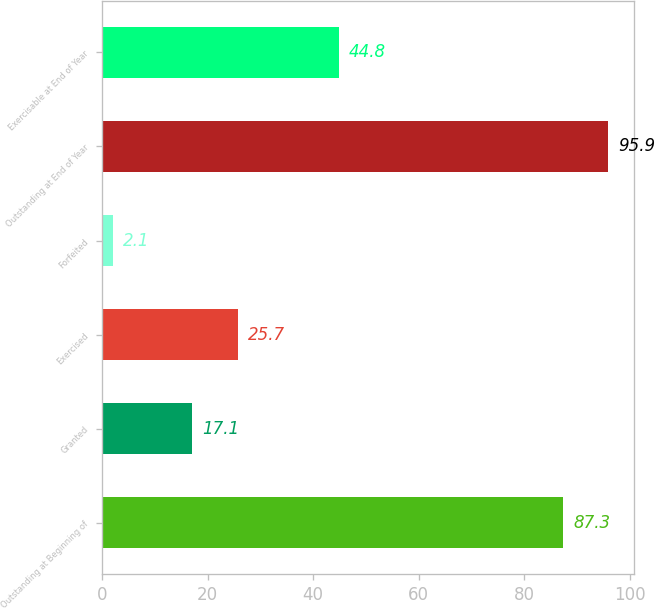<chart> <loc_0><loc_0><loc_500><loc_500><bar_chart><fcel>Outstanding at Beginning of<fcel>Granted<fcel>Exercised<fcel>Forfeited<fcel>Outstanding at End of Year<fcel>Exercisable at End of Year<nl><fcel>87.3<fcel>17.1<fcel>25.7<fcel>2.1<fcel>95.9<fcel>44.8<nl></chart> 